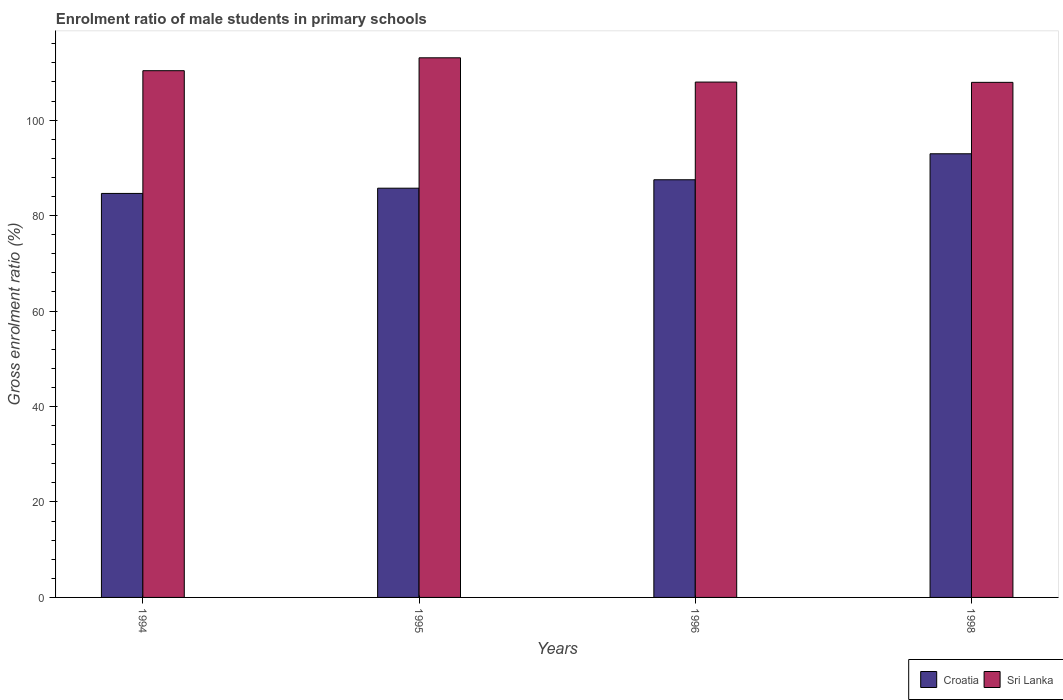Are the number of bars per tick equal to the number of legend labels?
Offer a terse response. Yes. How many bars are there on the 4th tick from the right?
Offer a terse response. 2. In how many cases, is the number of bars for a given year not equal to the number of legend labels?
Ensure brevity in your answer.  0. What is the enrolment ratio of male students in primary schools in Sri Lanka in 1995?
Provide a short and direct response. 113.06. Across all years, what is the maximum enrolment ratio of male students in primary schools in Croatia?
Provide a short and direct response. 92.95. Across all years, what is the minimum enrolment ratio of male students in primary schools in Sri Lanka?
Provide a succinct answer. 107.92. What is the total enrolment ratio of male students in primary schools in Sri Lanka in the graph?
Make the answer very short. 439.32. What is the difference between the enrolment ratio of male students in primary schools in Croatia in 1995 and that in 1996?
Keep it short and to the point. -1.77. What is the difference between the enrolment ratio of male students in primary schools in Croatia in 1994 and the enrolment ratio of male students in primary schools in Sri Lanka in 1995?
Provide a succinct answer. -28.41. What is the average enrolment ratio of male students in primary schools in Croatia per year?
Your answer should be very brief. 87.71. In the year 1995, what is the difference between the enrolment ratio of male students in primary schools in Croatia and enrolment ratio of male students in primary schools in Sri Lanka?
Ensure brevity in your answer.  -27.32. What is the ratio of the enrolment ratio of male students in primary schools in Croatia in 1996 to that in 1998?
Provide a short and direct response. 0.94. Is the difference between the enrolment ratio of male students in primary schools in Croatia in 1996 and 1998 greater than the difference between the enrolment ratio of male students in primary schools in Sri Lanka in 1996 and 1998?
Your answer should be very brief. No. What is the difference between the highest and the second highest enrolment ratio of male students in primary schools in Croatia?
Give a very brief answer. 5.44. What is the difference between the highest and the lowest enrolment ratio of male students in primary schools in Sri Lanka?
Offer a very short reply. 5.14. Is the sum of the enrolment ratio of male students in primary schools in Croatia in 1994 and 1996 greater than the maximum enrolment ratio of male students in primary schools in Sri Lanka across all years?
Your answer should be compact. Yes. What does the 1st bar from the left in 1995 represents?
Your response must be concise. Croatia. What does the 1st bar from the right in 1998 represents?
Make the answer very short. Sri Lanka. How many bars are there?
Your answer should be very brief. 8. Are all the bars in the graph horizontal?
Your answer should be compact. No. How many years are there in the graph?
Your answer should be very brief. 4. What is the difference between two consecutive major ticks on the Y-axis?
Give a very brief answer. 20. Are the values on the major ticks of Y-axis written in scientific E-notation?
Give a very brief answer. No. Does the graph contain any zero values?
Ensure brevity in your answer.  No. Where does the legend appear in the graph?
Offer a terse response. Bottom right. How many legend labels are there?
Keep it short and to the point. 2. How are the legend labels stacked?
Provide a short and direct response. Horizontal. What is the title of the graph?
Offer a terse response. Enrolment ratio of male students in primary schools. What is the label or title of the X-axis?
Offer a terse response. Years. What is the Gross enrolment ratio (%) in Croatia in 1994?
Give a very brief answer. 84.65. What is the Gross enrolment ratio (%) of Sri Lanka in 1994?
Offer a very short reply. 110.36. What is the Gross enrolment ratio (%) of Croatia in 1995?
Your answer should be very brief. 85.74. What is the Gross enrolment ratio (%) in Sri Lanka in 1995?
Your answer should be compact. 113.06. What is the Gross enrolment ratio (%) in Croatia in 1996?
Give a very brief answer. 87.51. What is the Gross enrolment ratio (%) in Sri Lanka in 1996?
Your answer should be very brief. 107.98. What is the Gross enrolment ratio (%) in Croatia in 1998?
Offer a terse response. 92.95. What is the Gross enrolment ratio (%) of Sri Lanka in 1998?
Provide a short and direct response. 107.92. Across all years, what is the maximum Gross enrolment ratio (%) of Croatia?
Offer a very short reply. 92.95. Across all years, what is the maximum Gross enrolment ratio (%) in Sri Lanka?
Provide a short and direct response. 113.06. Across all years, what is the minimum Gross enrolment ratio (%) of Croatia?
Your answer should be very brief. 84.65. Across all years, what is the minimum Gross enrolment ratio (%) of Sri Lanka?
Offer a terse response. 107.92. What is the total Gross enrolment ratio (%) of Croatia in the graph?
Give a very brief answer. 350.85. What is the total Gross enrolment ratio (%) in Sri Lanka in the graph?
Keep it short and to the point. 439.32. What is the difference between the Gross enrolment ratio (%) of Croatia in 1994 and that in 1995?
Provide a succinct answer. -1.1. What is the difference between the Gross enrolment ratio (%) in Sri Lanka in 1994 and that in 1995?
Provide a short and direct response. -2.7. What is the difference between the Gross enrolment ratio (%) in Croatia in 1994 and that in 1996?
Your response must be concise. -2.86. What is the difference between the Gross enrolment ratio (%) of Sri Lanka in 1994 and that in 1996?
Offer a very short reply. 2.38. What is the difference between the Gross enrolment ratio (%) in Croatia in 1994 and that in 1998?
Ensure brevity in your answer.  -8.31. What is the difference between the Gross enrolment ratio (%) of Sri Lanka in 1994 and that in 1998?
Keep it short and to the point. 2.44. What is the difference between the Gross enrolment ratio (%) of Croatia in 1995 and that in 1996?
Provide a short and direct response. -1.77. What is the difference between the Gross enrolment ratio (%) in Sri Lanka in 1995 and that in 1996?
Offer a very short reply. 5.08. What is the difference between the Gross enrolment ratio (%) in Croatia in 1995 and that in 1998?
Your response must be concise. -7.21. What is the difference between the Gross enrolment ratio (%) in Sri Lanka in 1995 and that in 1998?
Your answer should be very brief. 5.14. What is the difference between the Gross enrolment ratio (%) of Croatia in 1996 and that in 1998?
Ensure brevity in your answer.  -5.44. What is the difference between the Gross enrolment ratio (%) in Sri Lanka in 1996 and that in 1998?
Your answer should be compact. 0.06. What is the difference between the Gross enrolment ratio (%) of Croatia in 1994 and the Gross enrolment ratio (%) of Sri Lanka in 1995?
Your response must be concise. -28.41. What is the difference between the Gross enrolment ratio (%) of Croatia in 1994 and the Gross enrolment ratio (%) of Sri Lanka in 1996?
Give a very brief answer. -23.33. What is the difference between the Gross enrolment ratio (%) of Croatia in 1994 and the Gross enrolment ratio (%) of Sri Lanka in 1998?
Provide a succinct answer. -23.27. What is the difference between the Gross enrolment ratio (%) in Croatia in 1995 and the Gross enrolment ratio (%) in Sri Lanka in 1996?
Keep it short and to the point. -22.24. What is the difference between the Gross enrolment ratio (%) in Croatia in 1995 and the Gross enrolment ratio (%) in Sri Lanka in 1998?
Ensure brevity in your answer.  -22.18. What is the difference between the Gross enrolment ratio (%) in Croatia in 1996 and the Gross enrolment ratio (%) in Sri Lanka in 1998?
Provide a succinct answer. -20.41. What is the average Gross enrolment ratio (%) of Croatia per year?
Give a very brief answer. 87.71. What is the average Gross enrolment ratio (%) in Sri Lanka per year?
Your answer should be very brief. 109.83. In the year 1994, what is the difference between the Gross enrolment ratio (%) of Croatia and Gross enrolment ratio (%) of Sri Lanka?
Ensure brevity in your answer.  -25.71. In the year 1995, what is the difference between the Gross enrolment ratio (%) of Croatia and Gross enrolment ratio (%) of Sri Lanka?
Your answer should be compact. -27.32. In the year 1996, what is the difference between the Gross enrolment ratio (%) in Croatia and Gross enrolment ratio (%) in Sri Lanka?
Your answer should be compact. -20.47. In the year 1998, what is the difference between the Gross enrolment ratio (%) of Croatia and Gross enrolment ratio (%) of Sri Lanka?
Make the answer very short. -14.96. What is the ratio of the Gross enrolment ratio (%) in Croatia in 1994 to that in 1995?
Your answer should be compact. 0.99. What is the ratio of the Gross enrolment ratio (%) in Sri Lanka in 1994 to that in 1995?
Offer a very short reply. 0.98. What is the ratio of the Gross enrolment ratio (%) in Croatia in 1994 to that in 1996?
Offer a terse response. 0.97. What is the ratio of the Gross enrolment ratio (%) in Sri Lanka in 1994 to that in 1996?
Offer a terse response. 1.02. What is the ratio of the Gross enrolment ratio (%) of Croatia in 1994 to that in 1998?
Offer a very short reply. 0.91. What is the ratio of the Gross enrolment ratio (%) of Sri Lanka in 1994 to that in 1998?
Give a very brief answer. 1.02. What is the ratio of the Gross enrolment ratio (%) in Croatia in 1995 to that in 1996?
Your response must be concise. 0.98. What is the ratio of the Gross enrolment ratio (%) in Sri Lanka in 1995 to that in 1996?
Make the answer very short. 1.05. What is the ratio of the Gross enrolment ratio (%) in Croatia in 1995 to that in 1998?
Offer a very short reply. 0.92. What is the ratio of the Gross enrolment ratio (%) of Sri Lanka in 1995 to that in 1998?
Give a very brief answer. 1.05. What is the ratio of the Gross enrolment ratio (%) of Croatia in 1996 to that in 1998?
Provide a short and direct response. 0.94. What is the ratio of the Gross enrolment ratio (%) in Sri Lanka in 1996 to that in 1998?
Provide a succinct answer. 1. What is the difference between the highest and the second highest Gross enrolment ratio (%) of Croatia?
Your answer should be very brief. 5.44. What is the difference between the highest and the second highest Gross enrolment ratio (%) of Sri Lanka?
Provide a succinct answer. 2.7. What is the difference between the highest and the lowest Gross enrolment ratio (%) in Croatia?
Provide a succinct answer. 8.31. What is the difference between the highest and the lowest Gross enrolment ratio (%) in Sri Lanka?
Your answer should be compact. 5.14. 